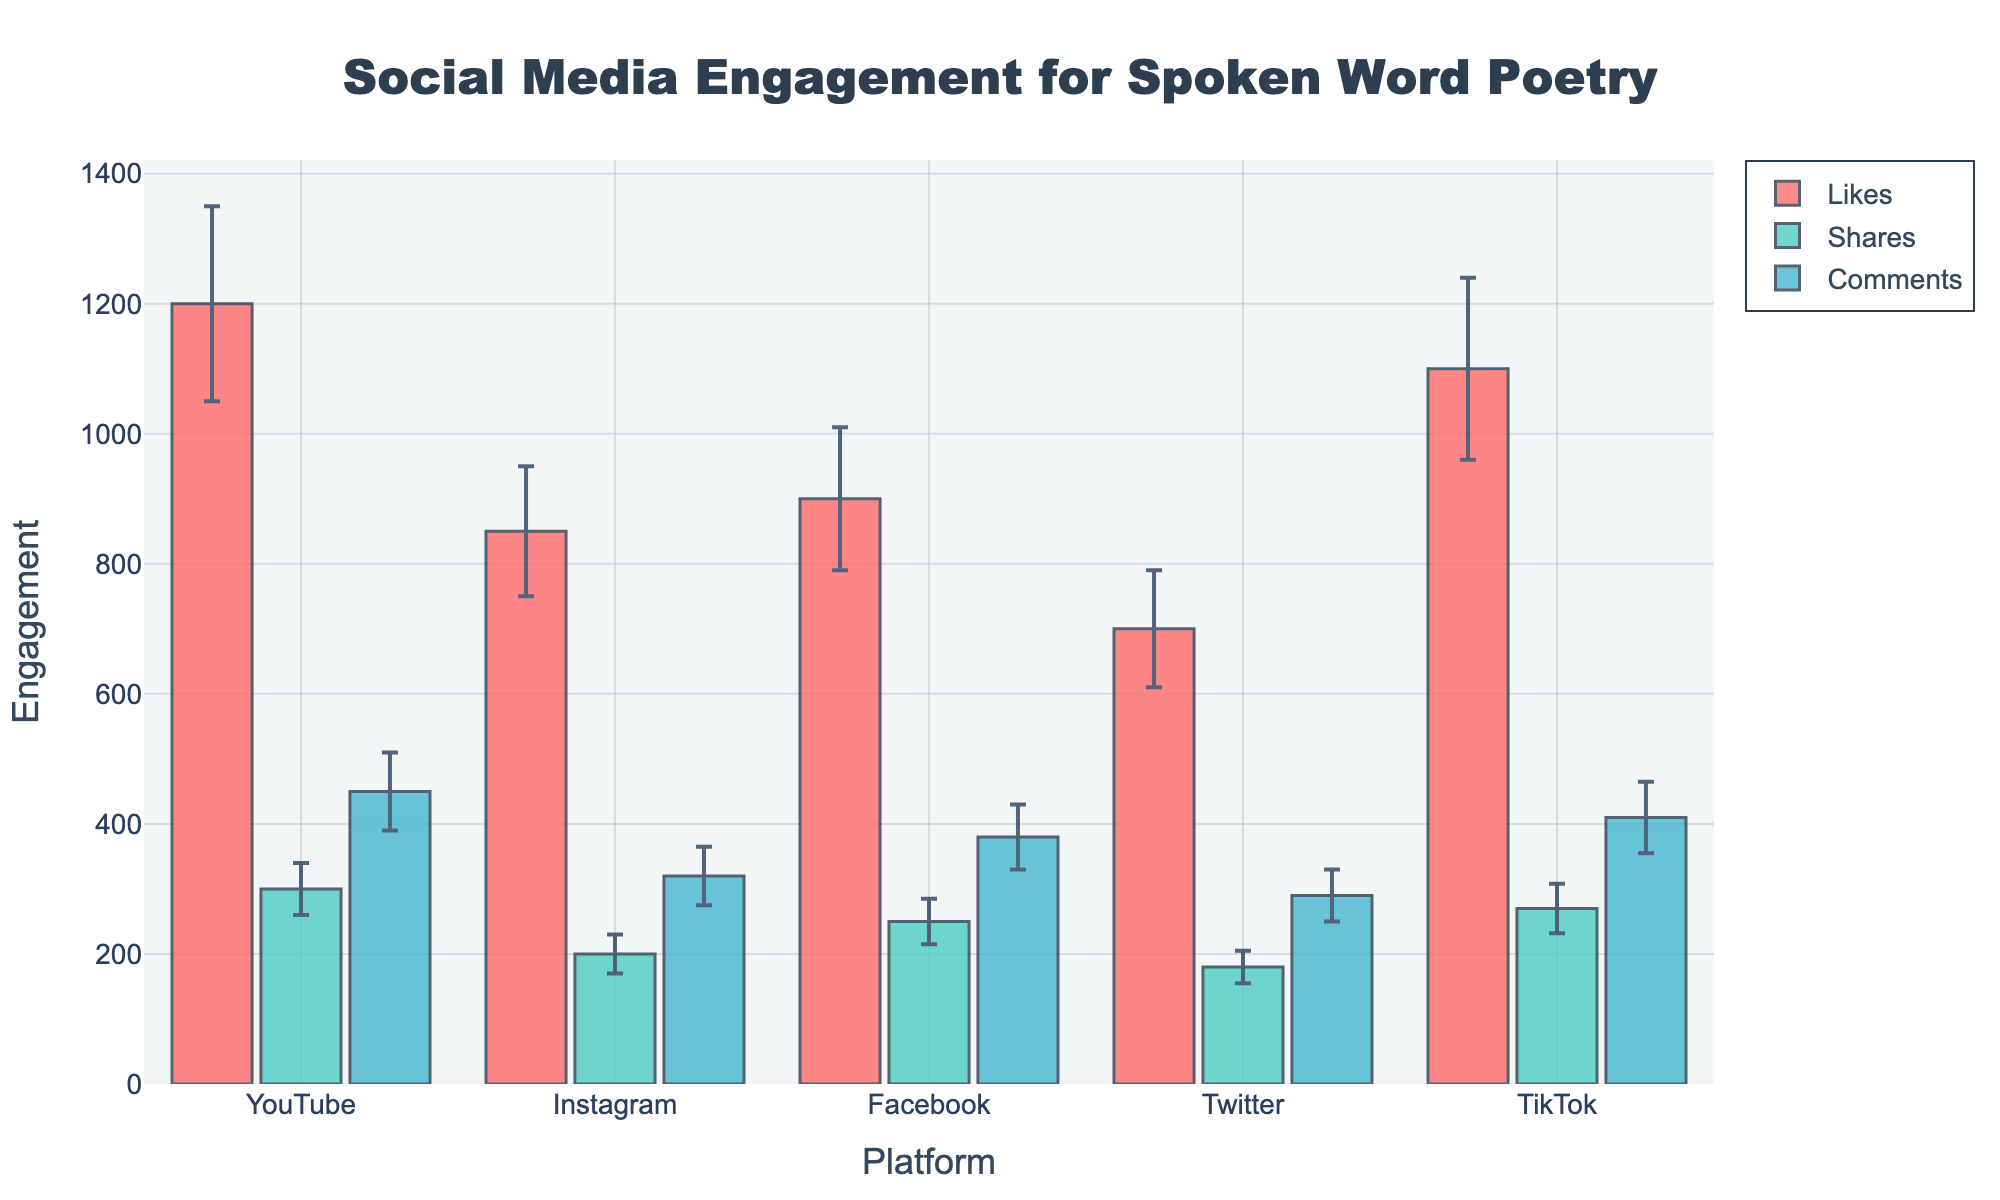What's the title of the chart? The title is typically located at the top of the chart. It provides an overview of what the chart is representing, which in this case is "Social Media Engagement for Spoken Word Poetry".
Answer: Social Media Engagement for Spoken Word Poetry What are the platforms being compared in the chart? By looking at the x-axis labels, we can see the names of each platform included in the comparison. These platforms are YouTube, Instagram, Facebook, Twitter, and TikTok.
Answer: YouTube, Instagram, Facebook, Twitter, TikTok Which platform has the highest average number of likes for spoken word poetry posts? To find which platform has the highest average number of likes, we look at the bar heights under the "Likes" category. YouTube shows the tallest bar for likes, which means it has the highest average number of likes.
Answer: YouTube What is the mean number of comments for Instagram posts? The y-values of the bar representing comments for Instagram provide this information. The mean number of comments for Instagram posts is 320, as indicated by the bar's height.
Answer: 320 Which metric shows the most variability (largest error bars) across all platforms? Error bars represent the standard deviation in the data. By observing the error bars, we notice that "Likes" appear to have the largest range of variability across most platforms.
Answer: Likes Compare the standard deviation of shares on YouTube and Facebook. Which one is greater? To compare the two, we look at the error bars for shares on both platforms. YouTube has a standard deviation of 40 while Facebook has a standard deviation of 35. Hence, YouTube's standard deviation is greater.
Answer: YouTube Out of all the platforms, which has the lowest average number of shares? We identify the lowest bar in the "Shares" category. Twitter has the lowest bar for shares indicating it has the lowest average number of shares, which is 180.
Answer: Twitter How do the average number of comments on TikTok compare to those on Twitter? TikTok has an average number of comments represented by a bar height of 410 while Twitter has 290. TikTok's average number of comments is greater than that of Twitter.
Answer: TikTok How much higher is the mean number of shares on TikTok compared to Instagram? We find the difference by subtracting Instagram's mean number of shares (200) from TikTok's mean number (270). The calculation is 270 - 200 = 70.
Answer: 70 If we were to average the mean number of likes across all platforms, what would that value be? To find the average, sum up the means for likes (1200 + 850 + 900 + 700 + 1100 = 4750) and divide by the number of platforms (5). This would be 4750 / 5 = 950.
Answer: 950 